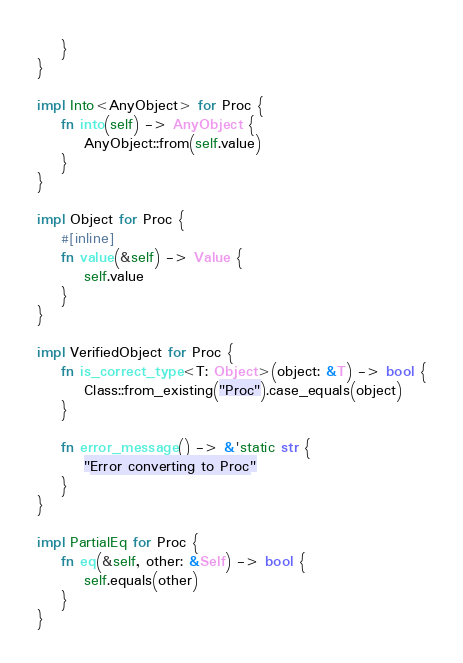<code> <loc_0><loc_0><loc_500><loc_500><_Rust_>    }
}

impl Into<AnyObject> for Proc {
    fn into(self) -> AnyObject {
        AnyObject::from(self.value)
    }
}

impl Object for Proc {
    #[inline]
    fn value(&self) -> Value {
        self.value
    }
}

impl VerifiedObject for Proc {
    fn is_correct_type<T: Object>(object: &T) -> bool {
        Class::from_existing("Proc").case_equals(object)
    }

    fn error_message() -> &'static str {
        "Error converting to Proc"
    }
}

impl PartialEq for Proc {
    fn eq(&self, other: &Self) -> bool {
        self.equals(other)
    }
}
</code> 